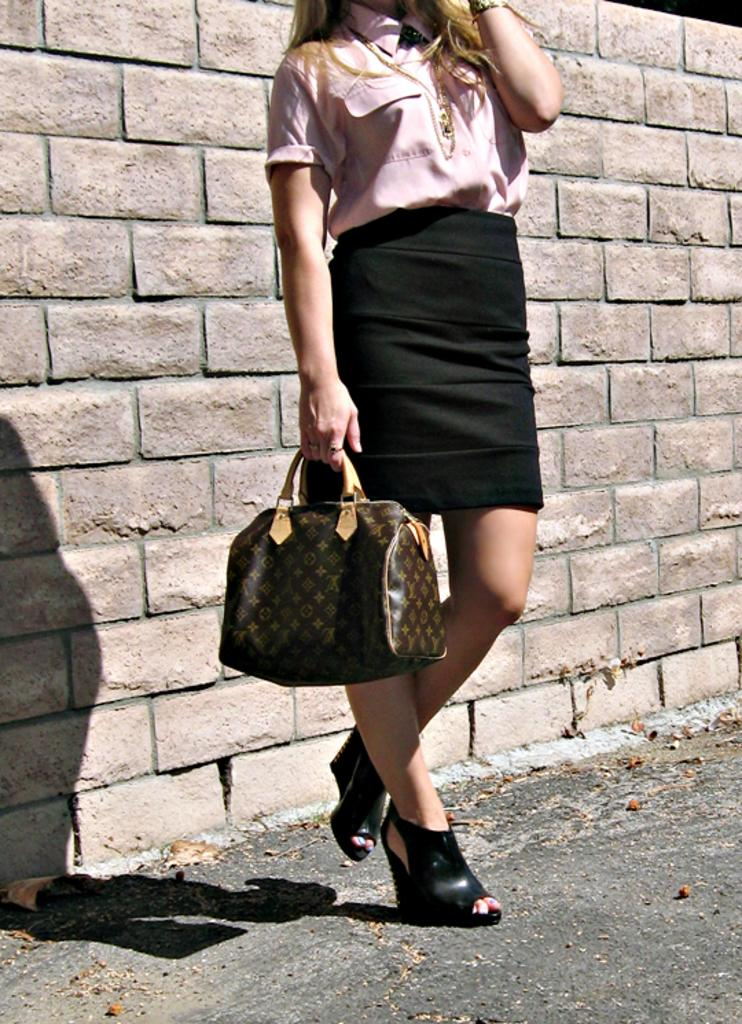Who is present in the image? There is a woman in the image. What is the woman holding in the image? The woman is holding a bag with her hands. What can be seen in the background of the image? There is a road and a wall in the image. Is there an umbrella visible in the room in the image? There is no room or umbrella present in the image. 